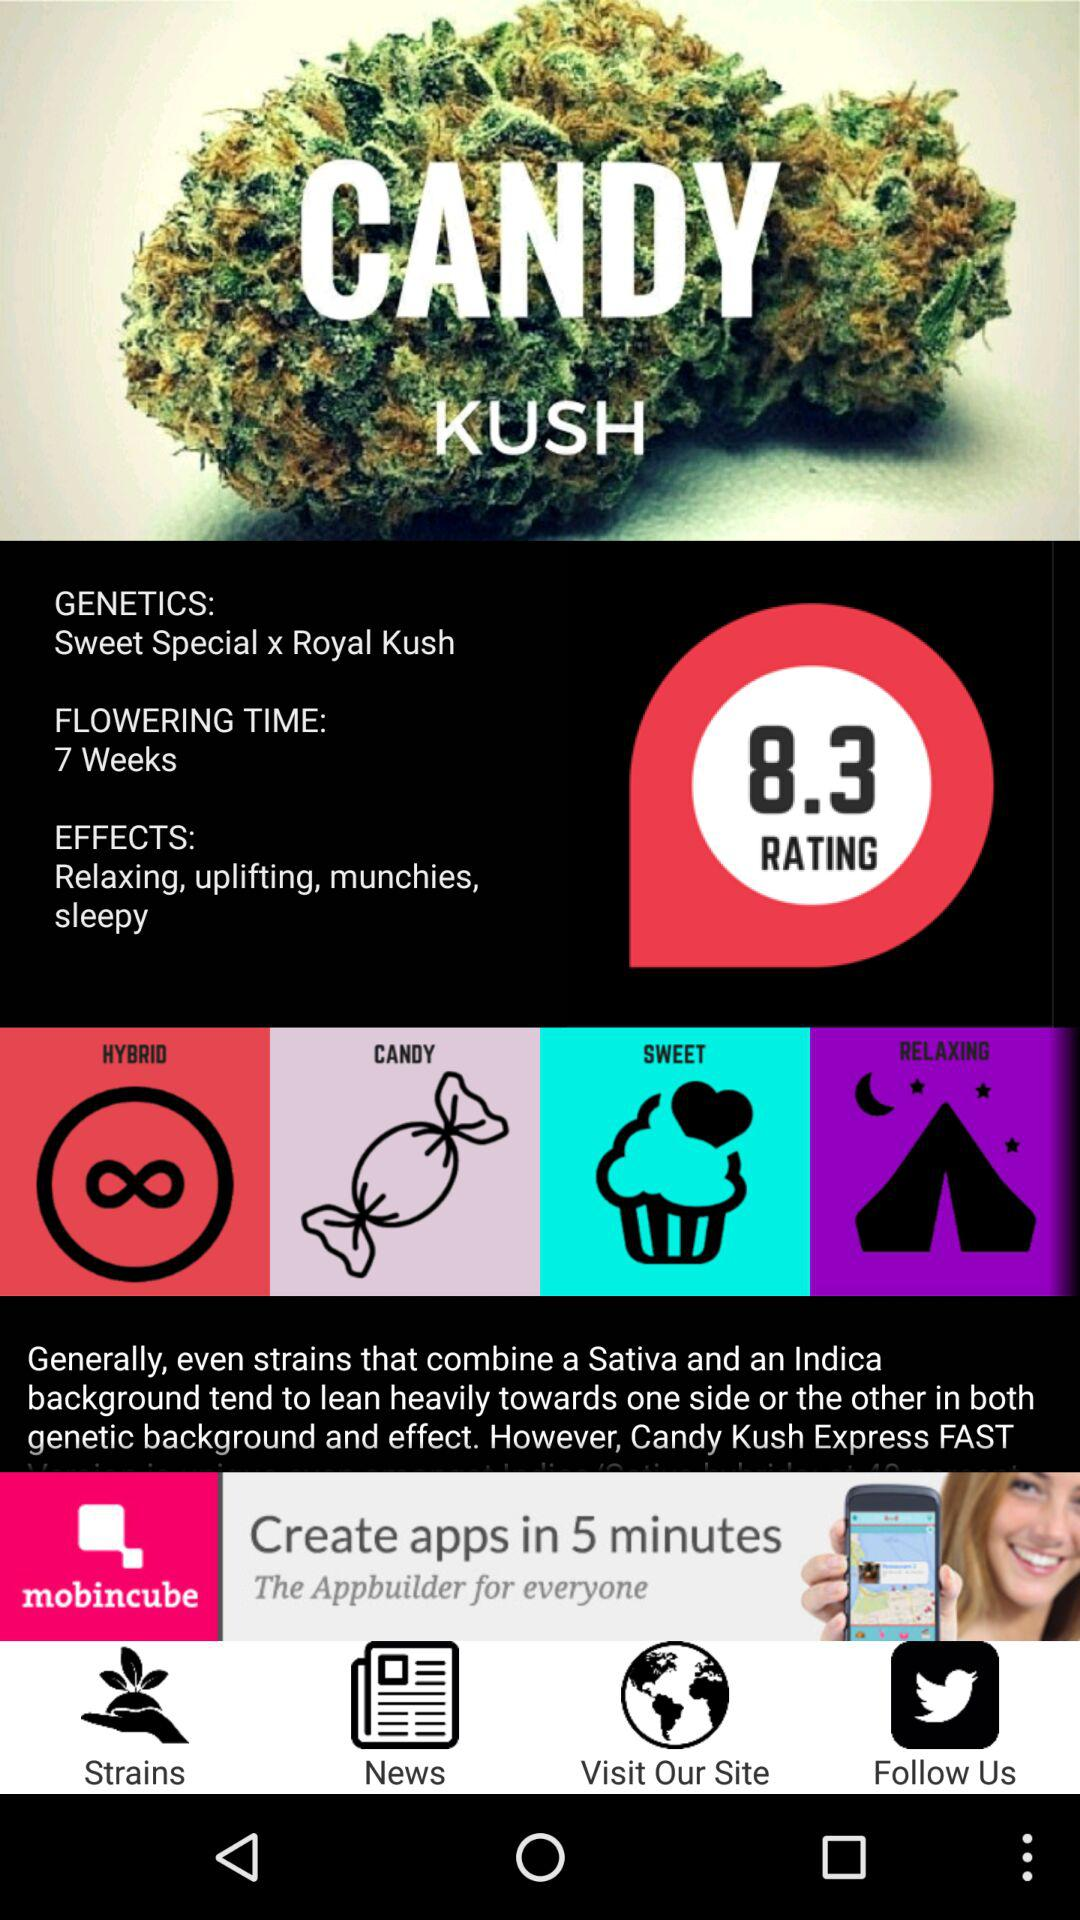What is the rating for "CANDY KUSH"? The rating for "CANDY KUSH" is 8.3. 